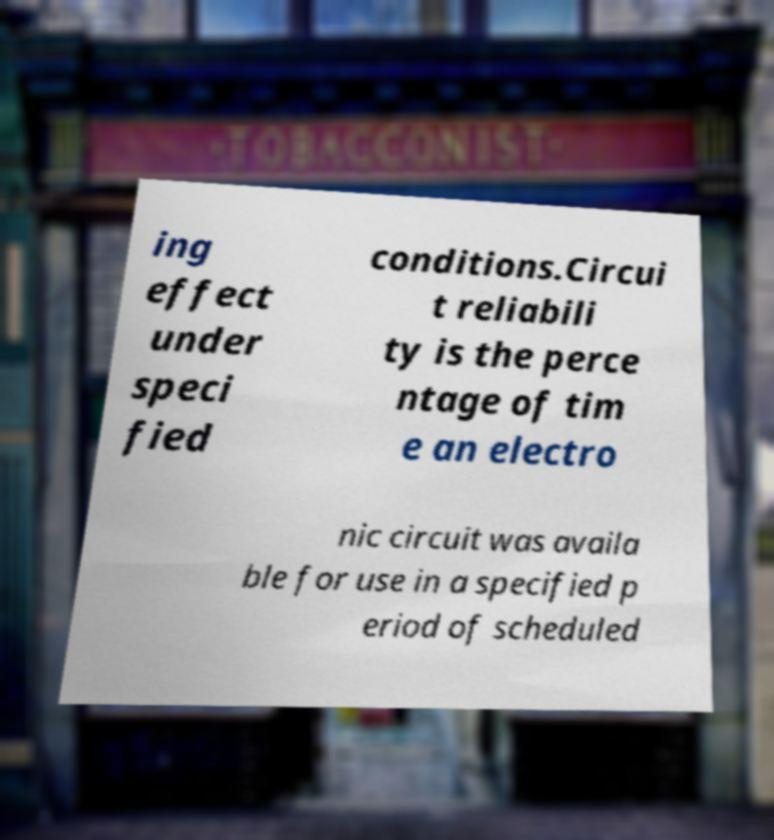What messages or text are displayed in this image? I need them in a readable, typed format. ing effect under speci fied conditions.Circui t reliabili ty is the perce ntage of tim e an electro nic circuit was availa ble for use in a specified p eriod of scheduled 